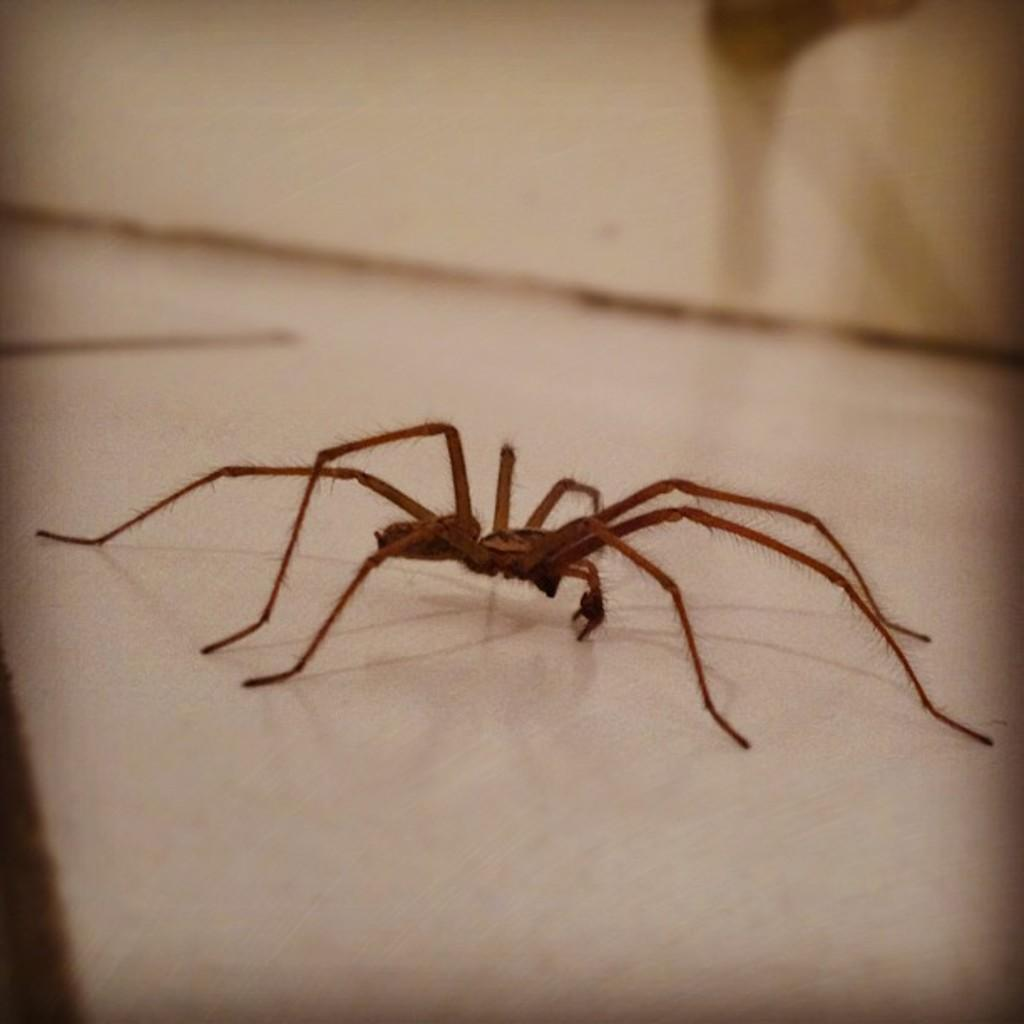What is the main subject of the image? The main subject of the image is a spider. What is the color of the surface on which the spider is located? The spider is on a white color surface. What is the opinion of the spider about the street in the image? There is no indication in the image that the spider has an opinion about a street, as the image only features a spider on a white color surface. 